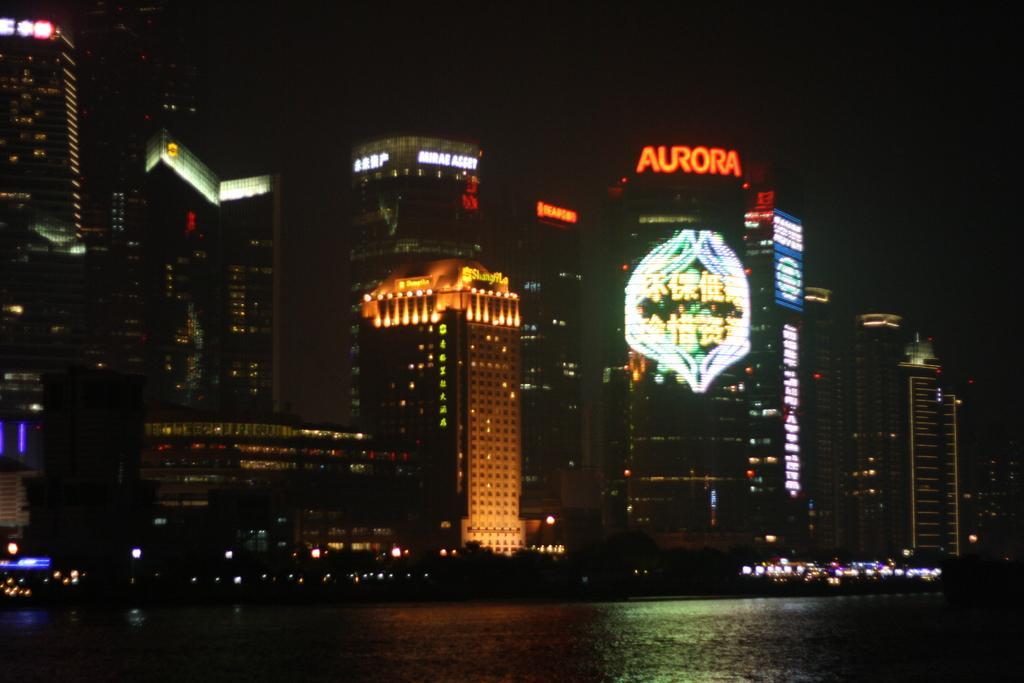Describe this image in one or two sentences. In the picture I can see the water and buildings. In the background I can see the sky. 